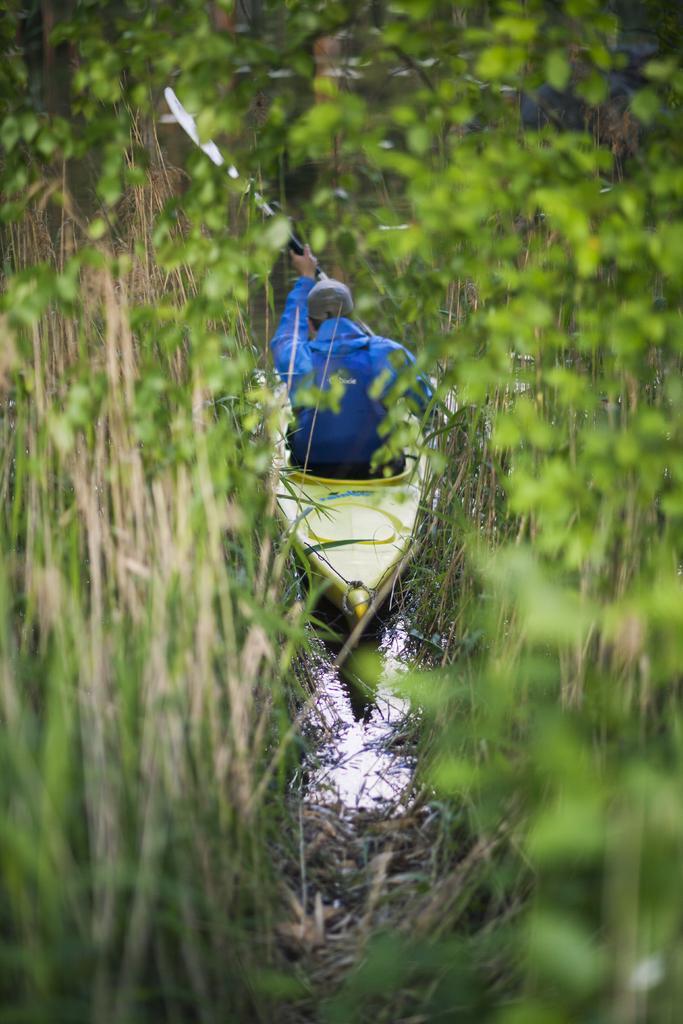Could you give a brief overview of what you see in this image? In this image, we can see a person on the boat which is in between plants. This person is holding a rower. 